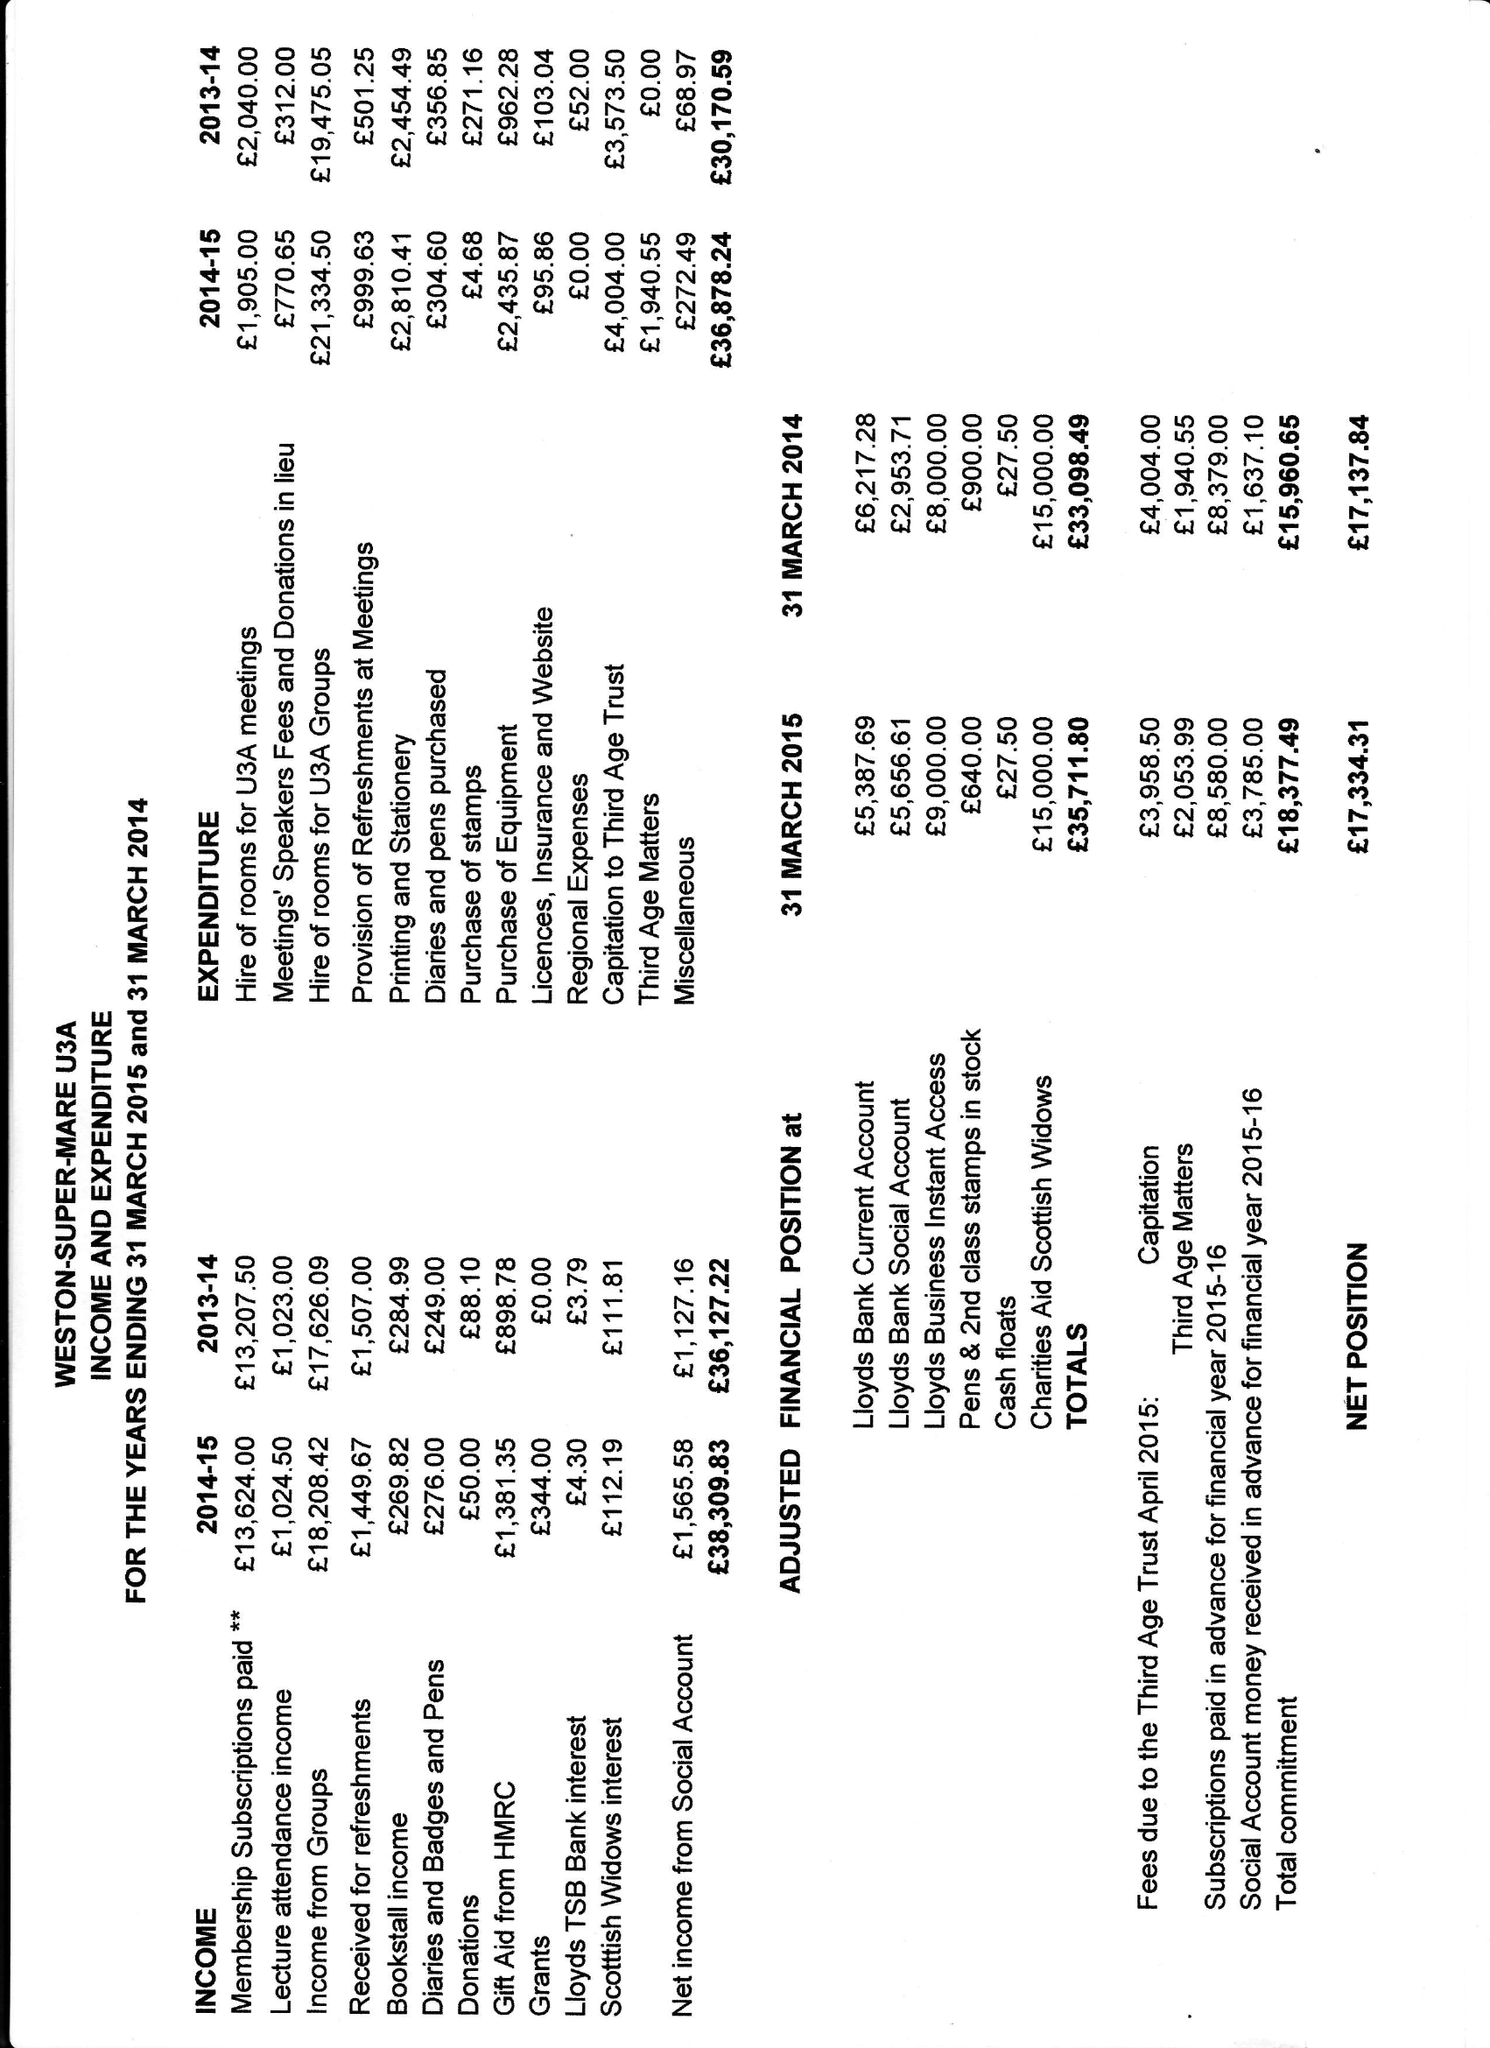What is the value for the address__post_town?
Answer the question using a single word or phrase. None 